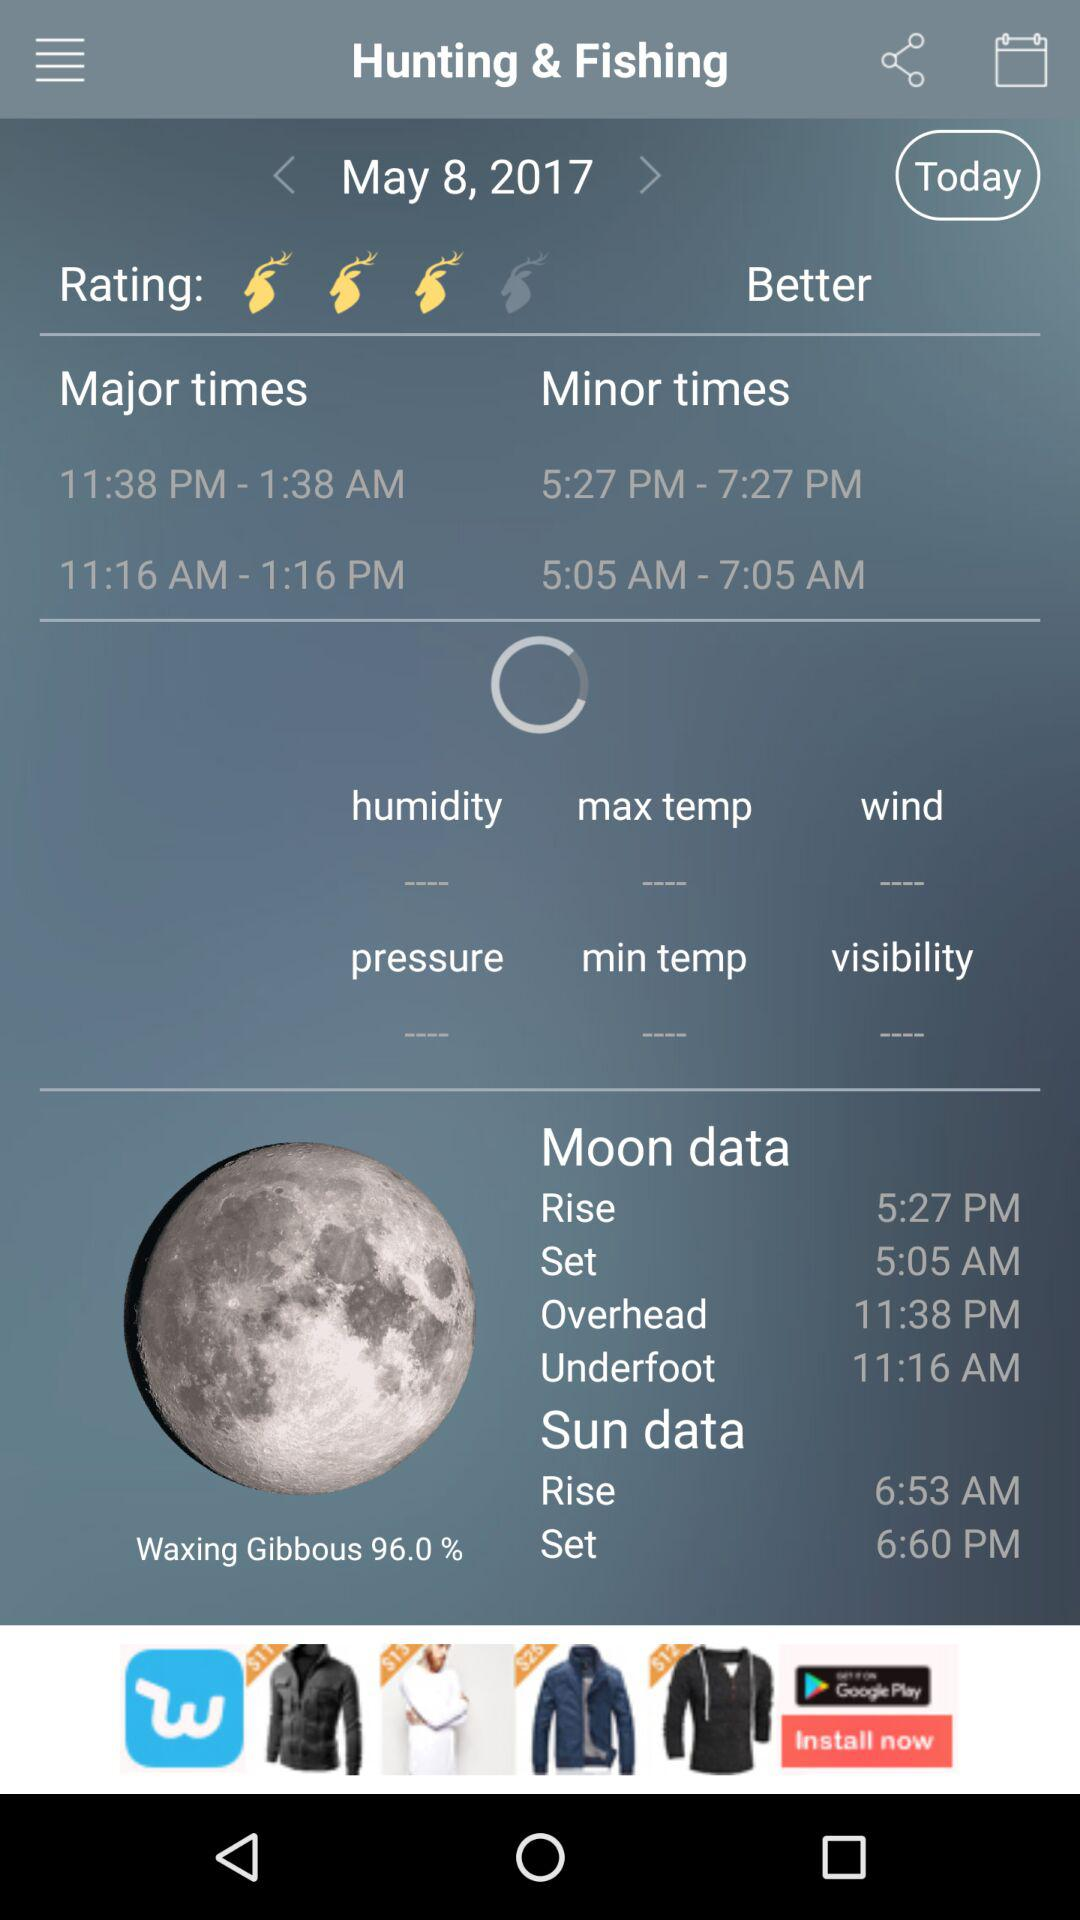What is the moon rise time? The time is 5:27 PM. 